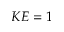Convert formula to latex. <formula><loc_0><loc_0><loc_500><loc_500>K E = 1</formula> 